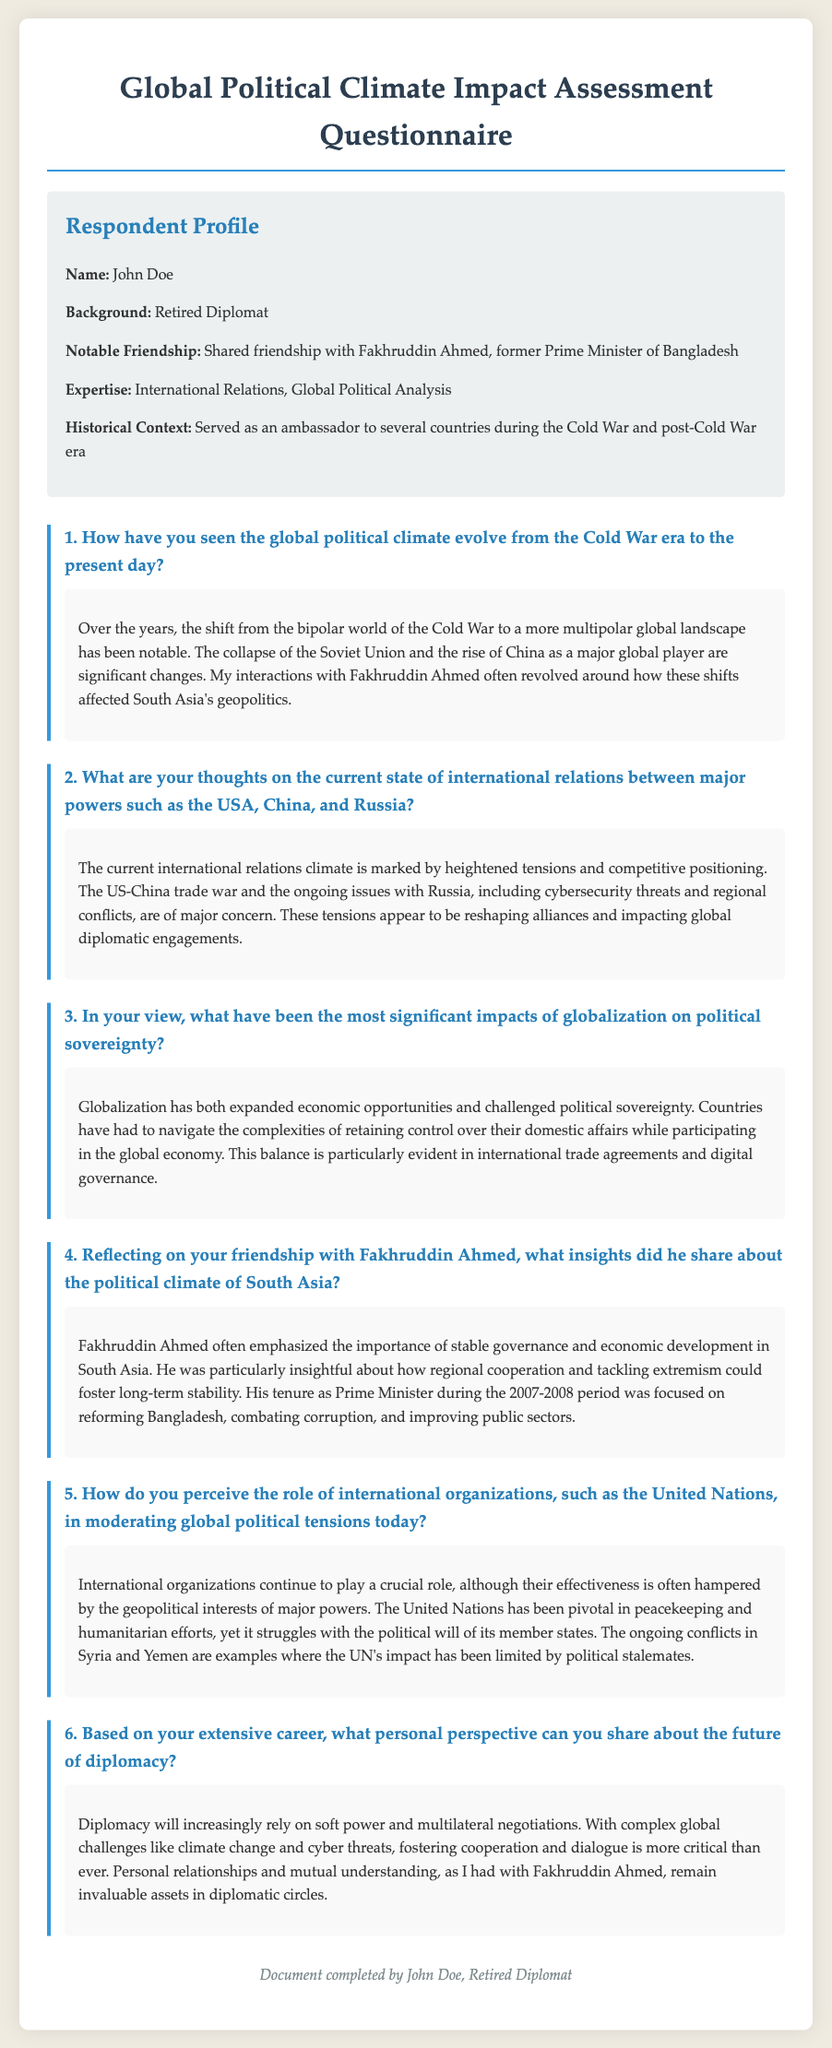What is the name of the respondent? The document clearly states the name of the respondent at the top under the Respondent Profile section.
Answer: John Doe What notable friendship is mentioned? The document highlights a notable friendship in the Respondent Profile section, which is significant in the context of the questionnaire.
Answer: Fakhruddin Ahmed What position did Fakhruddin Ahmed hold? The document mentions the former position of Fakhruddin Ahmed in relation to the respondent's profile.
Answer: Prime Minister of Bangladesh How many questions are in the questionnaire? The structure of the document shows that there are multiple questions numbered sequentially.
Answer: Six What is the primary focus of the respondent’s expertise? The document lists the respondent's area of expertise in the Respondent Profile section, indicating their professional background.
Answer: International Relations What key aspect of globalization is discussed in relation to political sovereignty? The respondent provides insights into the effects of globalization on political sovereignty that are summarized in the answers section.
Answer: Retaining control What did Fakhruddin Ahmed emphasize about South Asia? The document notes specific insights shared by Fakhruddin Ahmed regarding the political climate of South Asia.
Answer: Stable governance What global challenges are mentioned in relation to the future of diplomacy? The respondent mentions challenges that are influencing diplomacy as part of their personal perspective on future trends.
Answer: Climate change What organization is highlighted for its role in moderating global political tensions? The document refers specifically to an organization that has a significant impact on international relations.
Answer: United Nations 